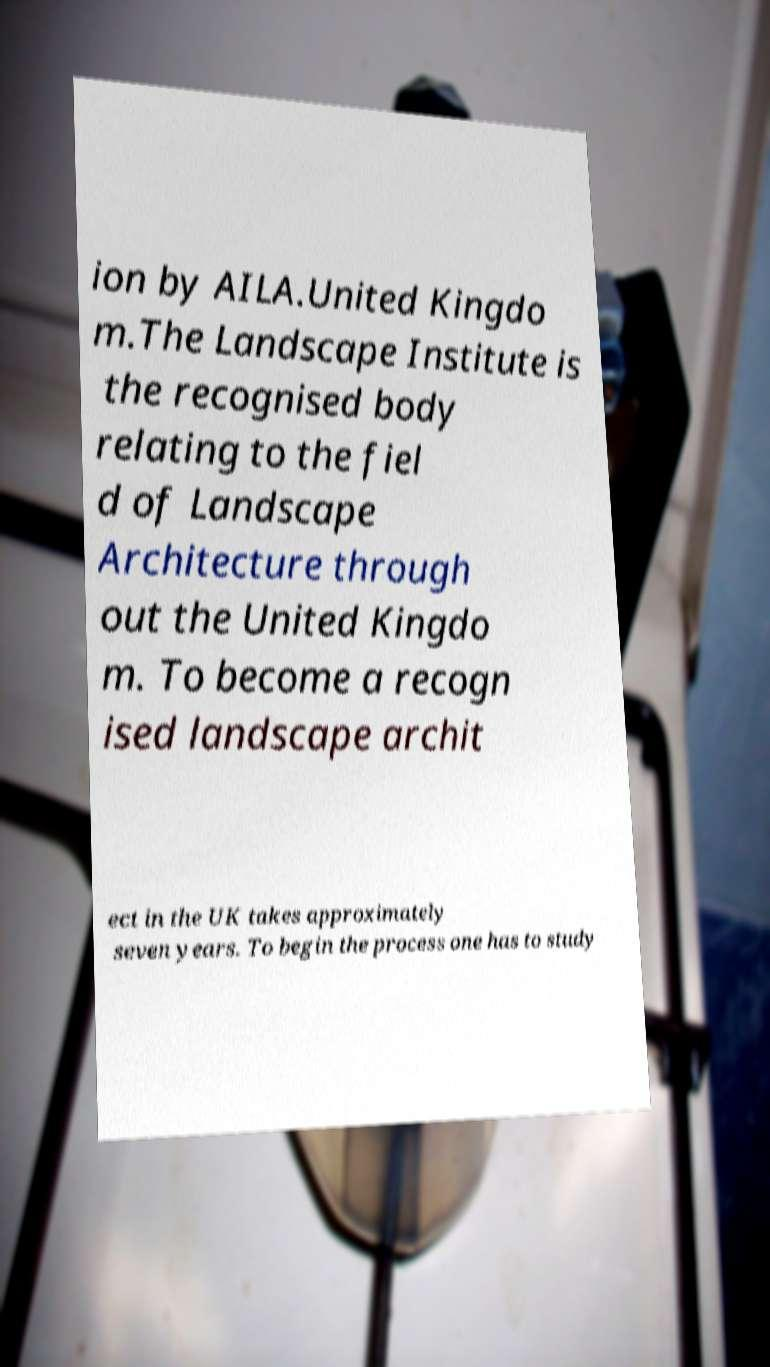Could you assist in decoding the text presented in this image and type it out clearly? ion by AILA.United Kingdo m.The Landscape Institute is the recognised body relating to the fiel d of Landscape Architecture through out the United Kingdo m. To become a recogn ised landscape archit ect in the UK takes approximately seven years. To begin the process one has to study 